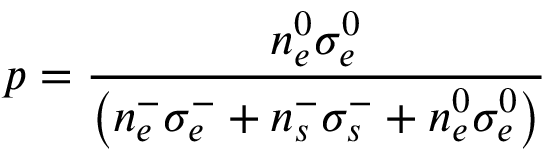Convert formula to latex. <formula><loc_0><loc_0><loc_500><loc_500>p = \frac { n _ { e } ^ { 0 } \sigma _ { e } ^ { 0 } } { \left ( n _ { e } ^ { - } \sigma _ { e } ^ { - } + n _ { s } ^ { - } \sigma _ { s } ^ { - } + n _ { e } ^ { 0 } \sigma _ { e } ^ { 0 } \right ) }</formula> 